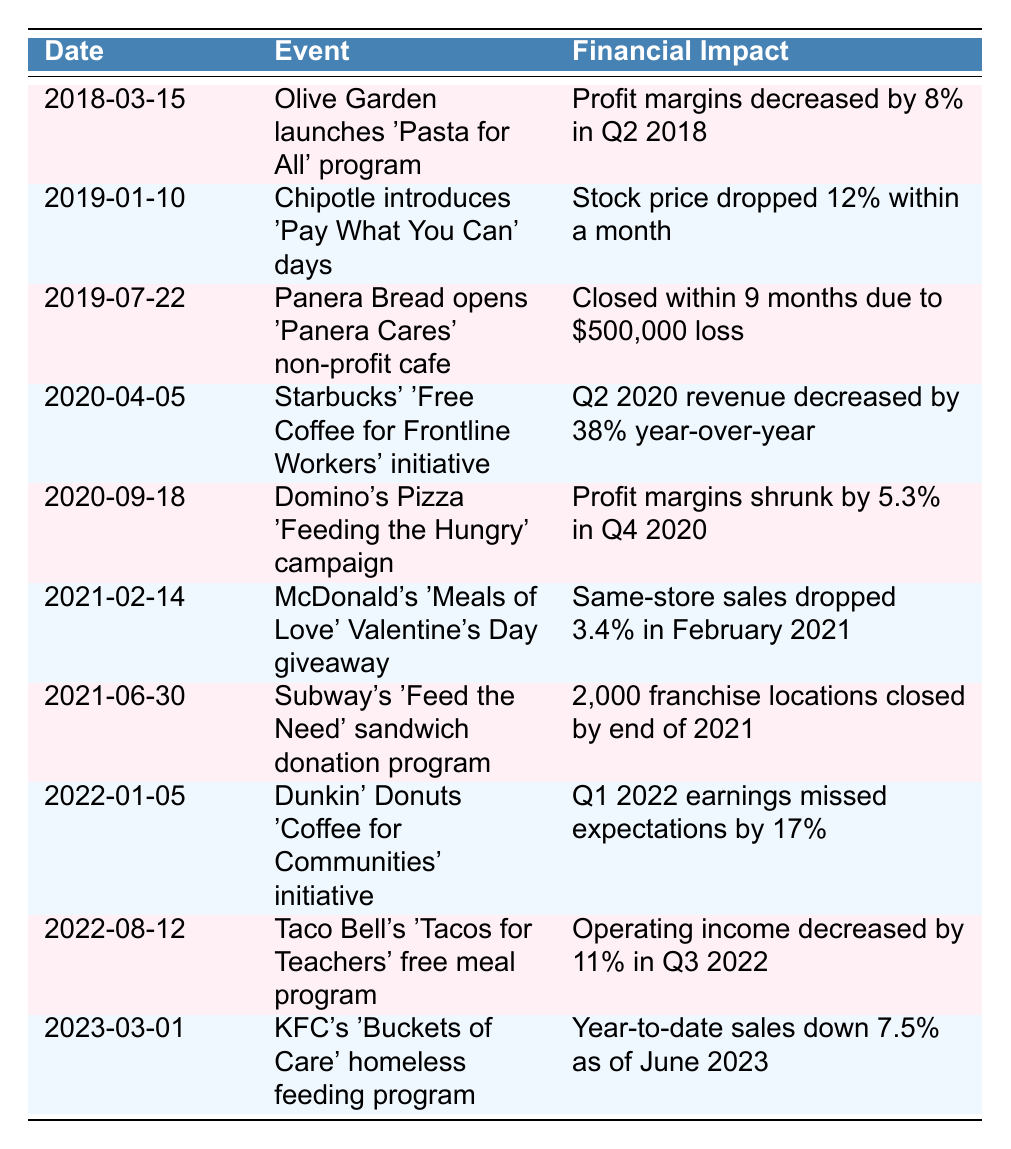What was the financial impact of the 'Pasta for All' program launched by Olive Garden? The table states that the 'Pasta for All' program led to a profit margin decrease of 8% in Q2 2018.
Answer: Profit margins decreased by 8% in Q2 2018 Which charitable initiative resulted in a loss of $500,000 within 9 months? The 'Panera Cares' non-profit cafe opened by Panera Bread is specifically mentioned in the table as having closed within 9 months due to a loss of $500,000.
Answer: Panera Bread's 'Panera Cares' non-profit cafe What percentage did Starbucks' initiative decrease their Q2 revenue year-over-year? The table shows that Starbucks' initiative for frontline workers caused a 38% decrease in Q2 2020 revenue compared to the previous year.
Answer: 38% How many franchise locations closed due to Subway's 'Feed the Need' program? According to the table, Subway's 'Feed the Need' program led to the closure of 2,000 franchise locations by the end of 2021.
Answer: 2,000 franchise locations Which restaurant experienced the highest percentage drop in stock price? Chipotle’s 'Pay What You Can' days saw a stock price drop of 12% within a month, which is the highest percentage drop listed in the table among the initiatives.
Answer: 12% Was there a decrease in sales for KFC's 'Buckets of Care' program as of June 2023? Yes, the table confirms that KFC's program resulted in year-to-date sales being down 7.5% by June 2023.
Answer: Yes Which two initiatives resulted in decreased operating income? The table indicates that Taco Bell's 'Tacos for Teachers' program saw an 11% decrease in operating income and that Starbucks' initiative reflected a significant drop in revenue. Both of these initiatives had negative financial impacts.
Answer: Taco Bell and Starbucks What is the average decline in profit margin for the five initiatives listed from 2018 to 2022? The relevant profit margin declines are 8%, 5.3%, 3.4%, 11%, and 38%. Adding these values gives 65.7% and dividing by 5 gives an average decline of 13.14%.
Answer: 13.14% Did any initiative lead to an increase in franchise locations? The table does not mention any initiative that led to an increase in franchise locations. Instead, Subway's program led to closures.
Answer: No 